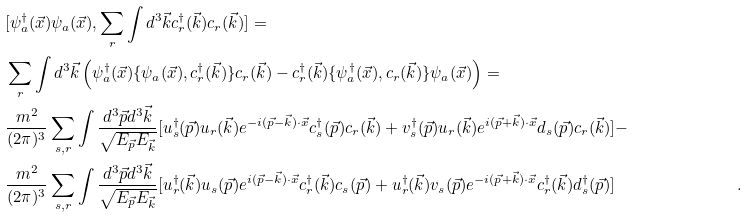<formula> <loc_0><loc_0><loc_500><loc_500>& [ \psi ^ { \dagger } _ { a } ( \vec { x } ) \psi _ { a } ( \vec { x } ) , \sum _ { r } \int { d ^ { 3 } \vec { k } } c ^ { \dagger } _ { r } ( \vec { k } ) c _ { r } ( \vec { k } ) ] = & \\ & \sum _ { r } \int { d ^ { 3 } \vec { k } } \left ( \psi ^ { \dagger } _ { a } ( \vec { x } ) \{ \psi _ { a } ( \vec { x } ) , c ^ { \dagger } _ { r } ( \vec { k } ) \} c _ { r } ( \vec { k } ) - c ^ { \dagger } _ { r } ( \vec { k } ) \{ \psi ^ { \dagger } _ { a } ( \vec { x } ) , c _ { r } ( \vec { k } ) \} \psi _ { a } ( \vec { x } ) \right ) = & \\ & \frac { m ^ { 2 } } { ( 2 \pi ) ^ { 3 } } \sum _ { s , r } \int \frac { { d ^ { 3 } \vec { p } } { d ^ { 3 } \vec { k } } } { \sqrt { E _ { \vec { p } } E _ { \vec { k } } } } [ u ^ { \dagger } _ { s } ( \vec { p } ) u _ { r } ( \vec { k } ) e ^ { - i ( \vec { p } - \vec { k } ) \cdot \vec { x } } c ^ { \dagger } _ { s } ( \vec { p } ) c _ { r } ( \vec { k } ) + v ^ { \dagger } _ { s } ( \vec { p } ) u _ { r } ( \vec { k } ) e ^ { i ( \vec { p } + \vec { k } ) \cdot \vec { x } } d _ { s } ( \vec { p } ) c _ { r } ( \vec { k } ) ] - & \\ & \frac { m ^ { 2 } } { ( 2 \pi ) ^ { 3 } } \sum _ { s , r } \int \frac { { d ^ { 3 } \vec { p } } { d ^ { 3 } \vec { k } } } { \sqrt { E _ { \vec { p } } E _ { \vec { k } } } } [ u ^ { \dagger } _ { r } ( \vec { k } ) u _ { s } ( \vec { p } ) e ^ { i ( \vec { p } - \vec { k } ) \cdot \vec { x } } c ^ { \dagger } _ { r } ( \vec { k } ) c _ { s } ( \vec { p } ) + u ^ { \dagger } _ { r } ( \vec { k } ) v _ { s } ( \vec { p } ) e ^ { - i ( \vec { p } + \vec { k } ) \cdot \vec { x } } c ^ { \dagger } _ { r } ( \vec { k } ) d ^ { \dagger } _ { s } ( \vec { p } ) ] & .</formula> 